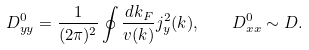<formula> <loc_0><loc_0><loc_500><loc_500>D ^ { 0 } _ { y y } = \frac { 1 } { ( 2 \pi ) ^ { 2 } } \oint \frac { d k _ { F } } { v ( { k } ) } j ^ { 2 } _ { y } ( { k } ) , \quad D ^ { 0 } _ { x x } \sim D .</formula> 